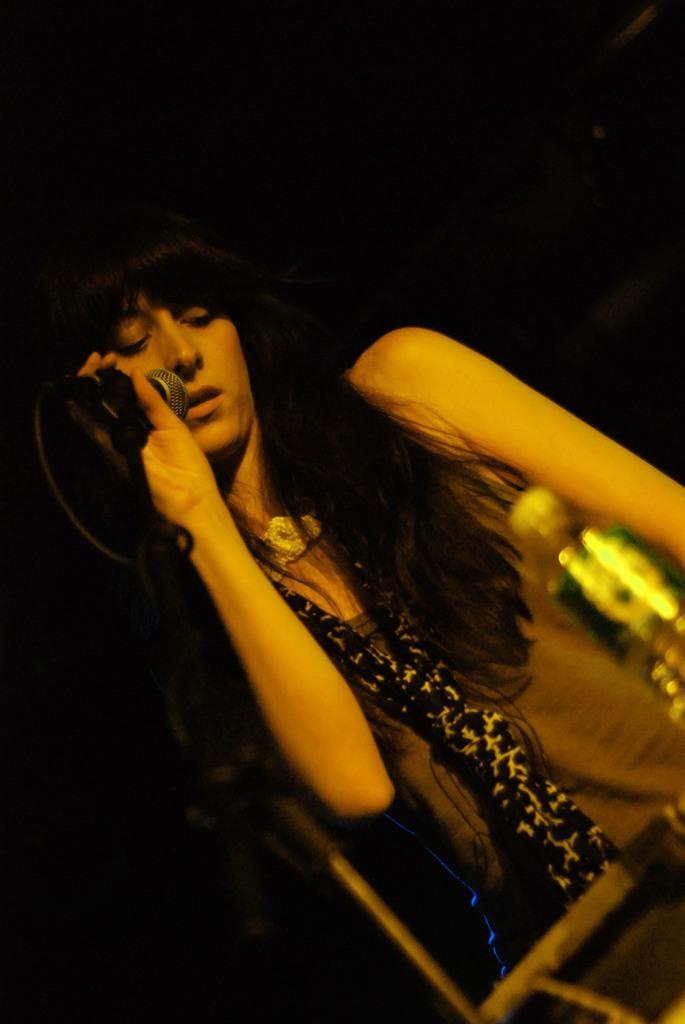Who is the main subject in the image? There is a woman in the image. What is the woman doing in the image? The woman is standing and holding a mic. What is placed in front of the woman? There is a bottle in front of the woman. What is the woman wearing around her neck? The woman is wearing a scarf. What type of string is being used to hold the actor's costume together in the image? There is no actor or costume present in the image; it features a woman holding a mic. 